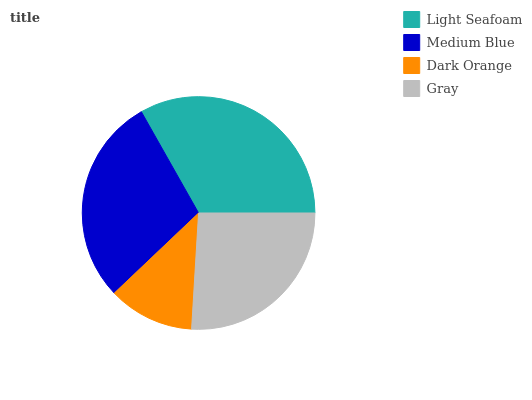Is Dark Orange the minimum?
Answer yes or no. Yes. Is Light Seafoam the maximum?
Answer yes or no. Yes. Is Medium Blue the minimum?
Answer yes or no. No. Is Medium Blue the maximum?
Answer yes or no. No. Is Light Seafoam greater than Medium Blue?
Answer yes or no. Yes. Is Medium Blue less than Light Seafoam?
Answer yes or no. Yes. Is Medium Blue greater than Light Seafoam?
Answer yes or no. No. Is Light Seafoam less than Medium Blue?
Answer yes or no. No. Is Medium Blue the high median?
Answer yes or no. Yes. Is Gray the low median?
Answer yes or no. Yes. Is Dark Orange the high median?
Answer yes or no. No. Is Light Seafoam the low median?
Answer yes or no. No. 